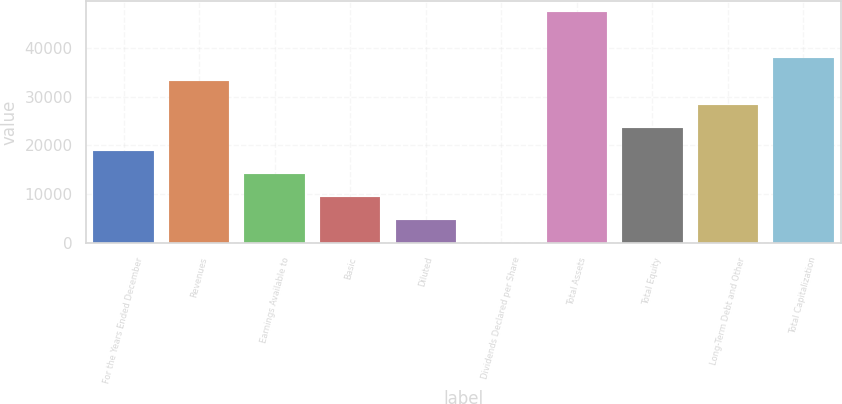Convert chart. <chart><loc_0><loc_0><loc_500><loc_500><bar_chart><fcel>For the Years Ended December<fcel>Revenues<fcel>Earnings Available to<fcel>Basic<fcel>Diluted<fcel>Dividends Declared per Share<fcel>Total Assets<fcel>Total Equity<fcel>Long-Term Debt and Other<fcel>Total Capitalization<nl><fcel>18931.7<fcel>33128.9<fcel>14199.3<fcel>9466.96<fcel>4734.58<fcel>2.2<fcel>47326<fcel>23664.1<fcel>28396.5<fcel>37861.2<nl></chart> 